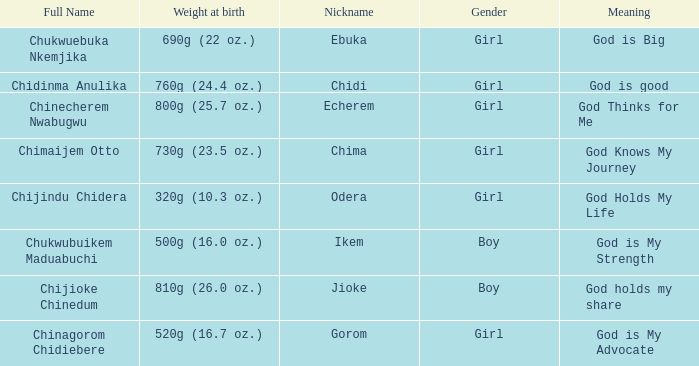What nickname has the meaning of God knows my journey? Chima. 